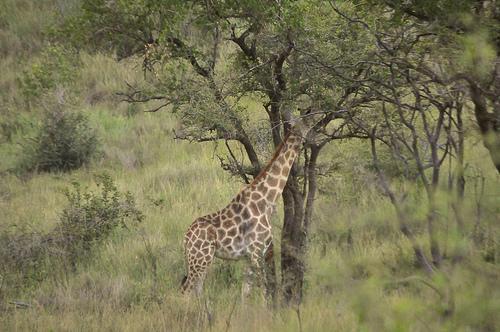How many giraffes are there?
Give a very brief answer. 1. 